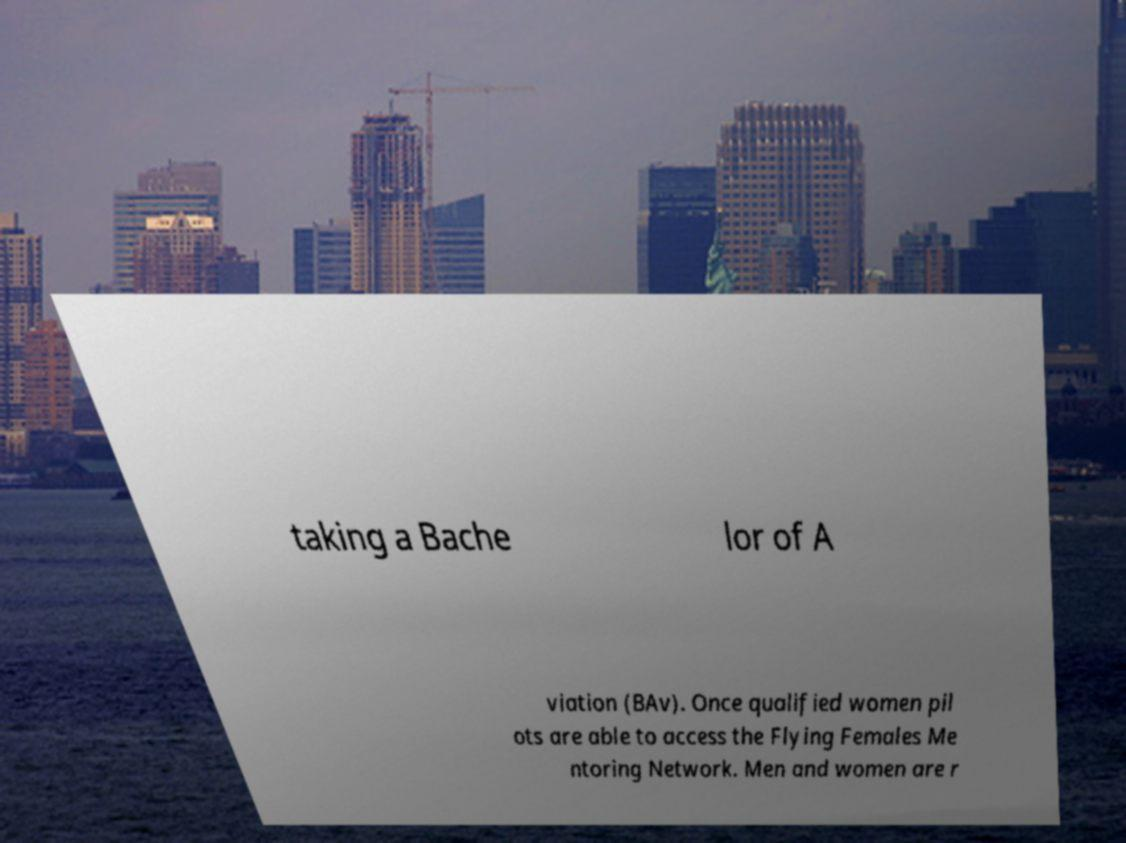What messages or text are displayed in this image? I need them in a readable, typed format. taking a Bache lor of A viation (BAv). Once qualified women pil ots are able to access the Flying Females Me ntoring Network. Men and women are r 